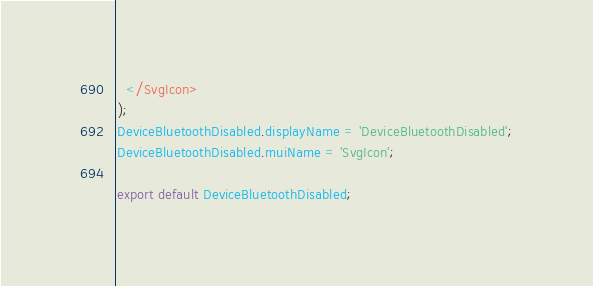Convert code to text. <code><loc_0><loc_0><loc_500><loc_500><_JavaScript_>  </SvgIcon>
);
DeviceBluetoothDisabled.displayName = 'DeviceBluetoothDisabled';
DeviceBluetoothDisabled.muiName = 'SvgIcon';

export default DeviceBluetoothDisabled;
</code> 